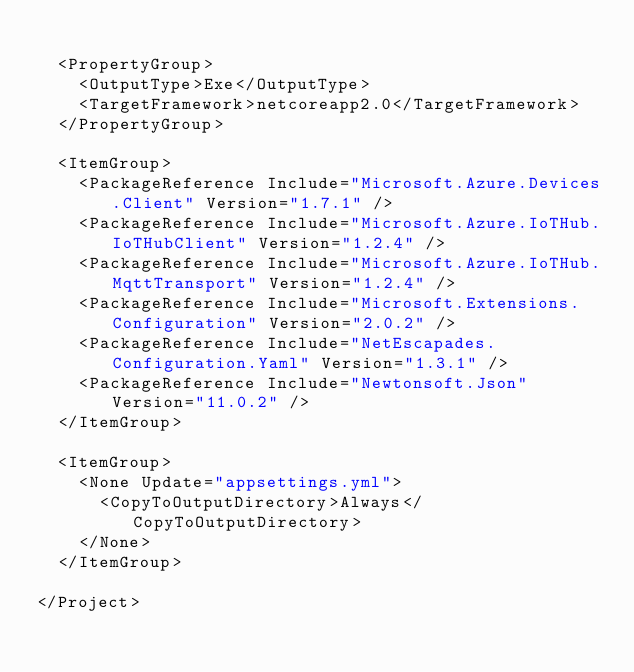Convert code to text. <code><loc_0><loc_0><loc_500><loc_500><_XML_>
  <PropertyGroup>
    <OutputType>Exe</OutputType>
    <TargetFramework>netcoreapp2.0</TargetFramework>
  </PropertyGroup>

  <ItemGroup>
    <PackageReference Include="Microsoft.Azure.Devices.Client" Version="1.7.1" />
    <PackageReference Include="Microsoft.Azure.IoTHub.IoTHubClient" Version="1.2.4" />
    <PackageReference Include="Microsoft.Azure.IoTHub.MqttTransport" Version="1.2.4" />
    <PackageReference Include="Microsoft.Extensions.Configuration" Version="2.0.2" />
    <PackageReference Include="NetEscapades.Configuration.Yaml" Version="1.3.1" />
    <PackageReference Include="Newtonsoft.Json" Version="11.0.2" />
  </ItemGroup>

  <ItemGroup>
    <None Update="appsettings.yml">
      <CopyToOutputDirectory>Always</CopyToOutputDirectory>
    </None>
  </ItemGroup>

</Project>
</code> 